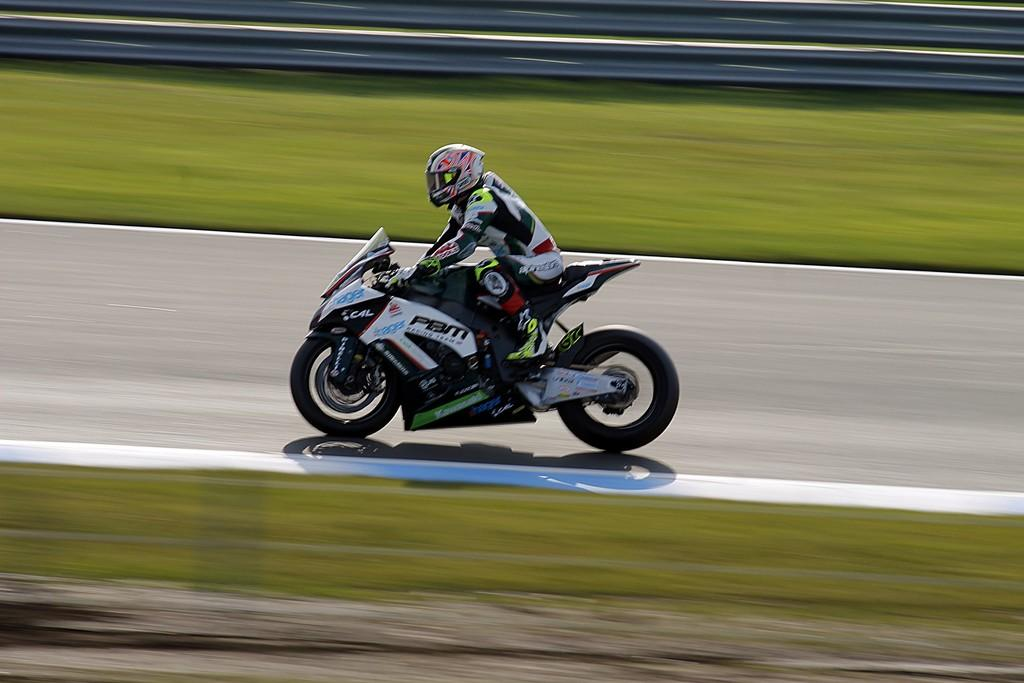What is the person in the image doing? The person is riding a sports bike in the image. Where is the person riding the bike? The person is on the road. Can you describe any specific features of the image? The image appears to contain a glass element. What is visible at the top of the image? There is a fence visible at the top of the image. What type of fruit is being pumped in the image? There is no fruit or pump present in the image. 